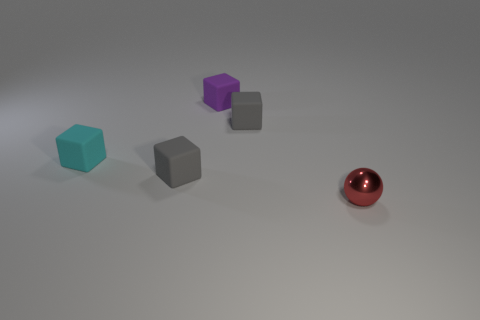Subtract all cyan balls. Subtract all brown cylinders. How many balls are left? 1 Add 5 purple matte things. How many objects exist? 10 Subtract all balls. How many objects are left? 4 Subtract all small purple rubber cubes. Subtract all small cyan things. How many objects are left? 3 Add 3 tiny red metal things. How many tiny red metal things are left? 4 Add 4 purple blocks. How many purple blocks exist? 5 Subtract 1 cyan blocks. How many objects are left? 4 